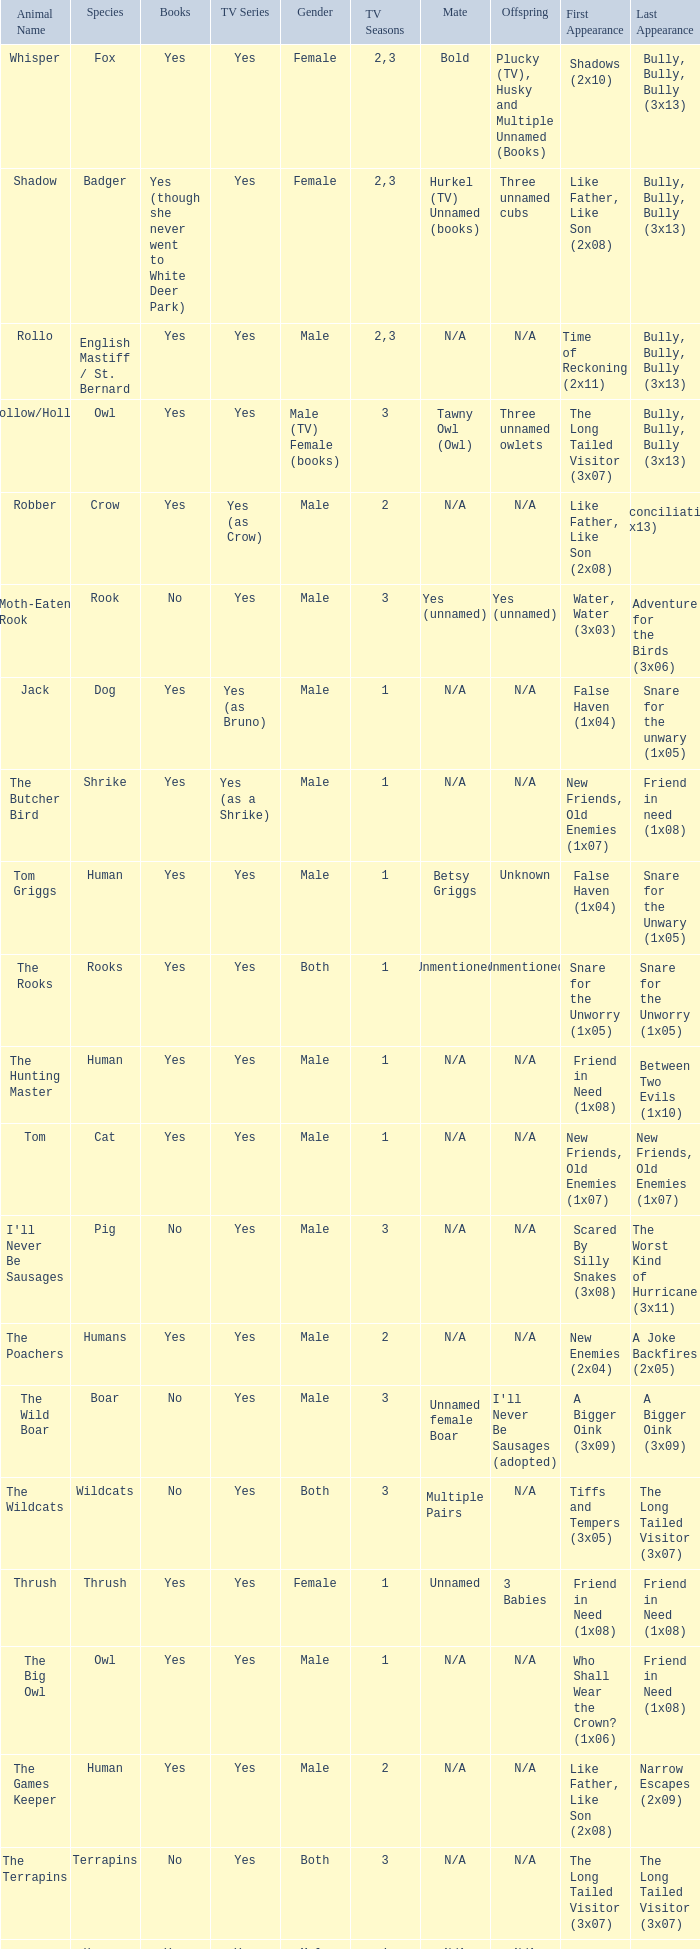What is the mate for Last Appearance of bully, bully, bully (3x13) for the animal named hollow/holly later than season 1? Tawny Owl (Owl). 